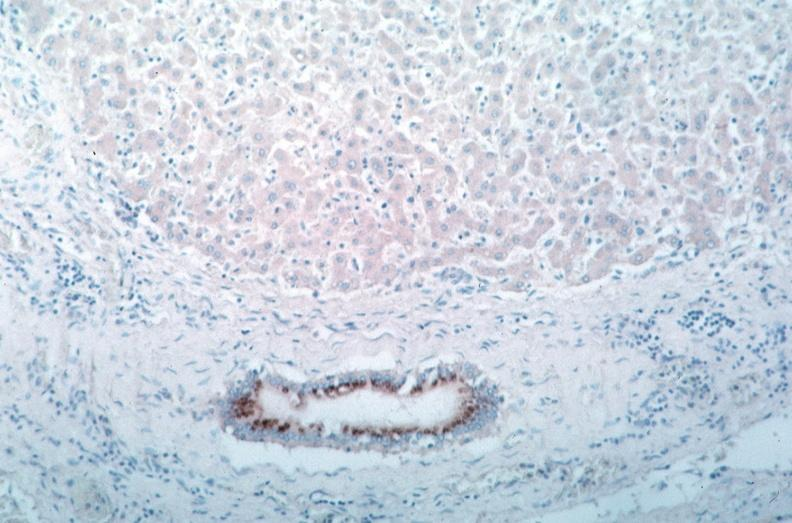what spotted fever, immunoperoxidase staining vessels for rickettsia rickettsii?
Answer the question using a single word or phrase. Rocky mountain 